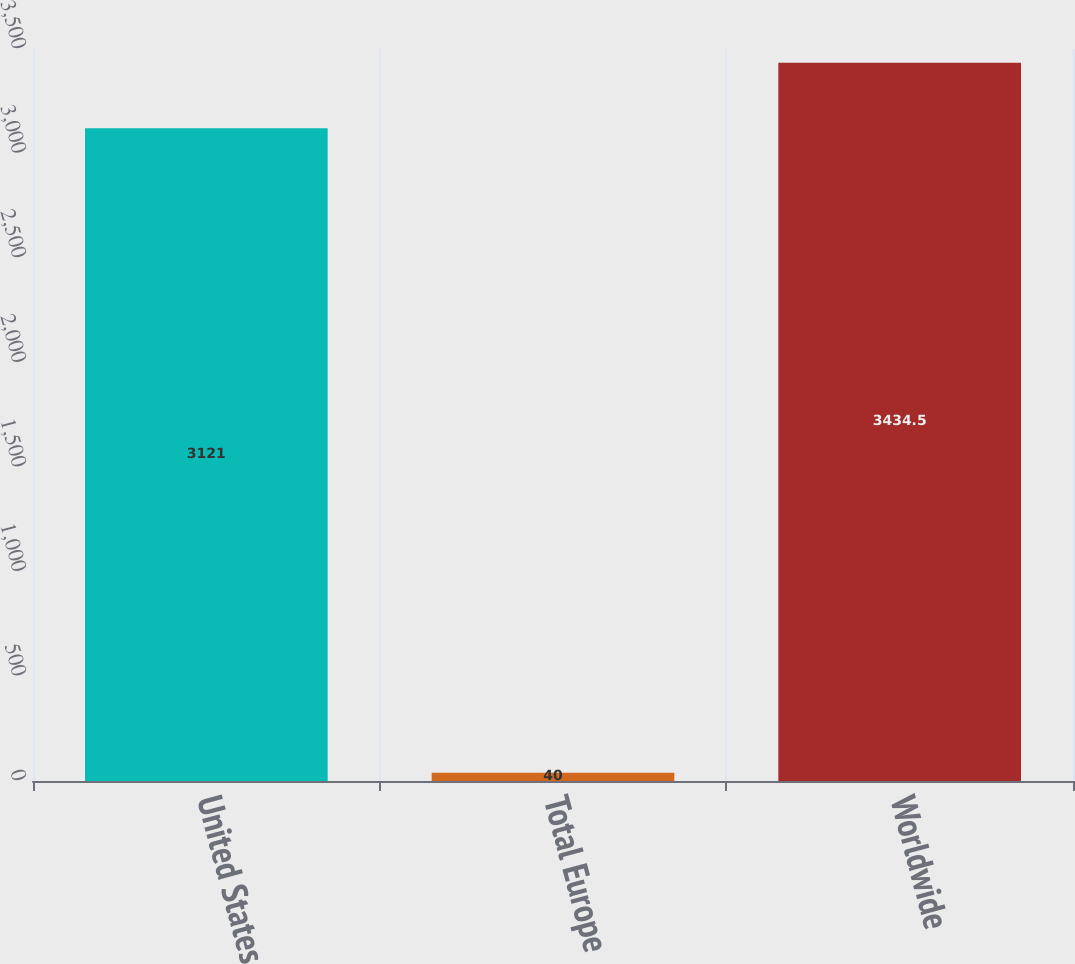Convert chart to OTSL. <chart><loc_0><loc_0><loc_500><loc_500><bar_chart><fcel>United States<fcel>Total Europe<fcel>Worldwide<nl><fcel>3121<fcel>40<fcel>3434.5<nl></chart> 